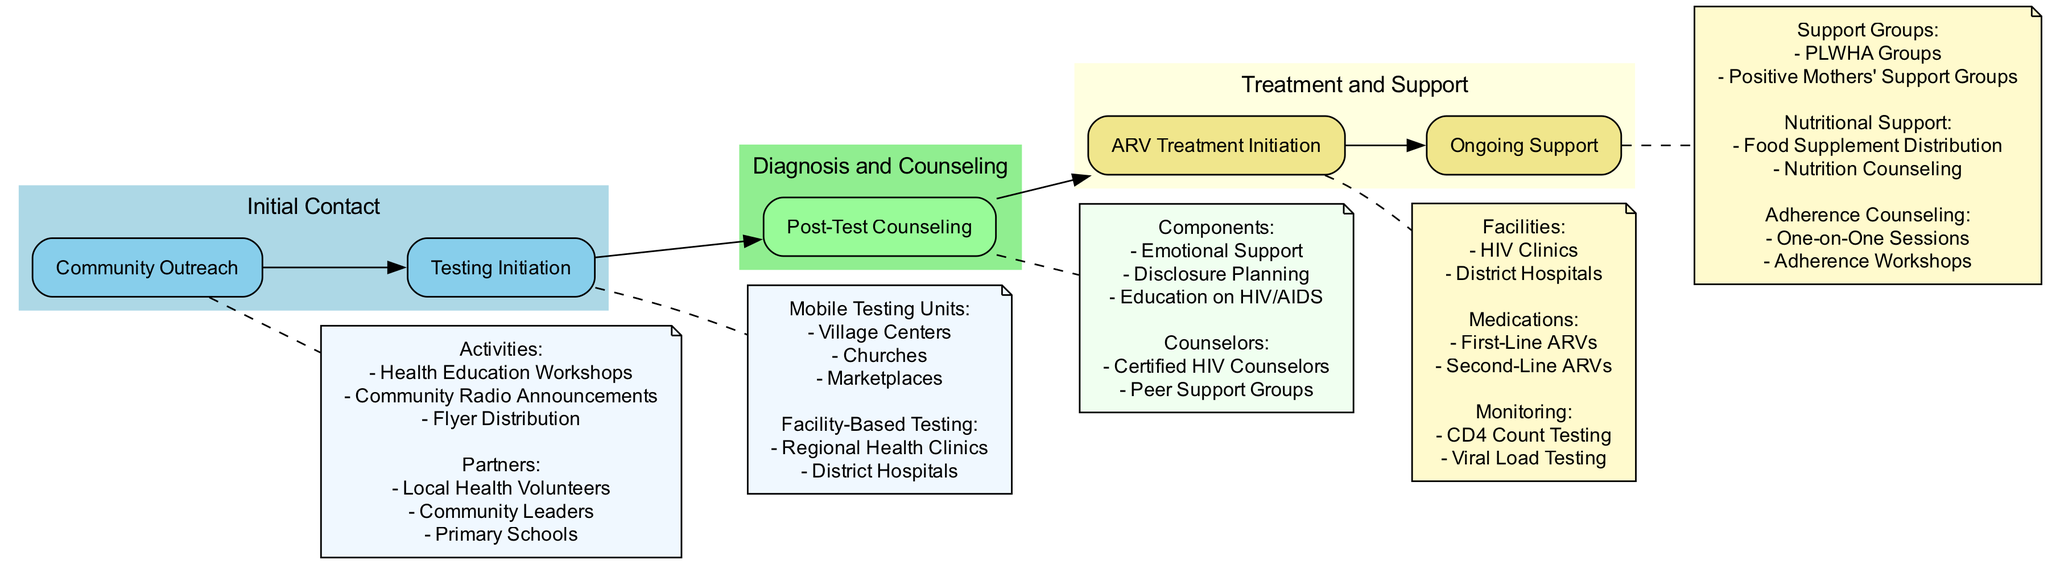What are the two main stages following the Initial Contact? The diagram shows the main stages that follow the Initial Contact, which are "Diagnosis and Counseling" and "Treatment and Support." By looking at the connections from the "Initial Contact," I can see that these two stages are directly connected to it.
Answer: Diagnosis and Counseling, Treatment and Support How many activities are listed under Community Outreach? Under the "Community Outreach" node, there is a note listing three specific activities: "Health Education Workshops," "Community Radio Announcements," and "Flyer Distribution." Counting these activities gives us the total number.
Answer: 3 Which facilities are mentioned for ARV Treatment Initiation? The "ARV Treatment Initiation" node indicates that there are two types of facilities where the treatment can begin: "HIV Clinics" and "District Hospitals." These are explicitly listed in the details of the node.
Answer: HIV Clinics, District Hospitals What types of support groups are included in Ongoing Support? In the "Ongoing Support" section, there are two types of support groups identified: "People Living with HIV/AIDS (PLWHA) Groups" and "Positive Mothers' Support Groups." This concludes the support types provided in the diagram.
Answer: PLWHA Groups, Positive Mothers' Support Groups What is the first step after Testing Initiation according to the pathway? The diagram shows that after "Testing Initiation," the next step is "Post-Test Counseling." I can confirm this by following the arrow from "Testing Initiation" to "Post-Test Counseling."
Answer: Post-Test Counseling How many different locations are specified for Mobile Testing Units? The "Mobile Testing Units" node provides three different locations: "Village Centers," "Churches," and "Marketplaces." Counting these locations allows us to determine the total number.
Answer: 3 What counseling methods are included under Adherence Counseling? The node for "Adherence Counseling" lists two methods: "One-on-One Sessions" and "Adherence Workshops." These methods detail the approaches used for counseling on adherence.
Answer: One-on-One Sessions, Adherence Workshops What follows after Post-Test Counseling in the pathway? According to the diagram, the step that follows "Post-Test Counseling" is "ARV Treatment Initiation." This shows the linear progression from counseling to treatment in the pathway.
Answer: ARV Treatment Initiation How many types of ARV medications are specified in the diagram? The "ARV Treatment Initiation" details mention two types of ARV medications: "First-Line ARVs" and "Second-Line ARVs." Counting these types gives the total.
Answer: 2 